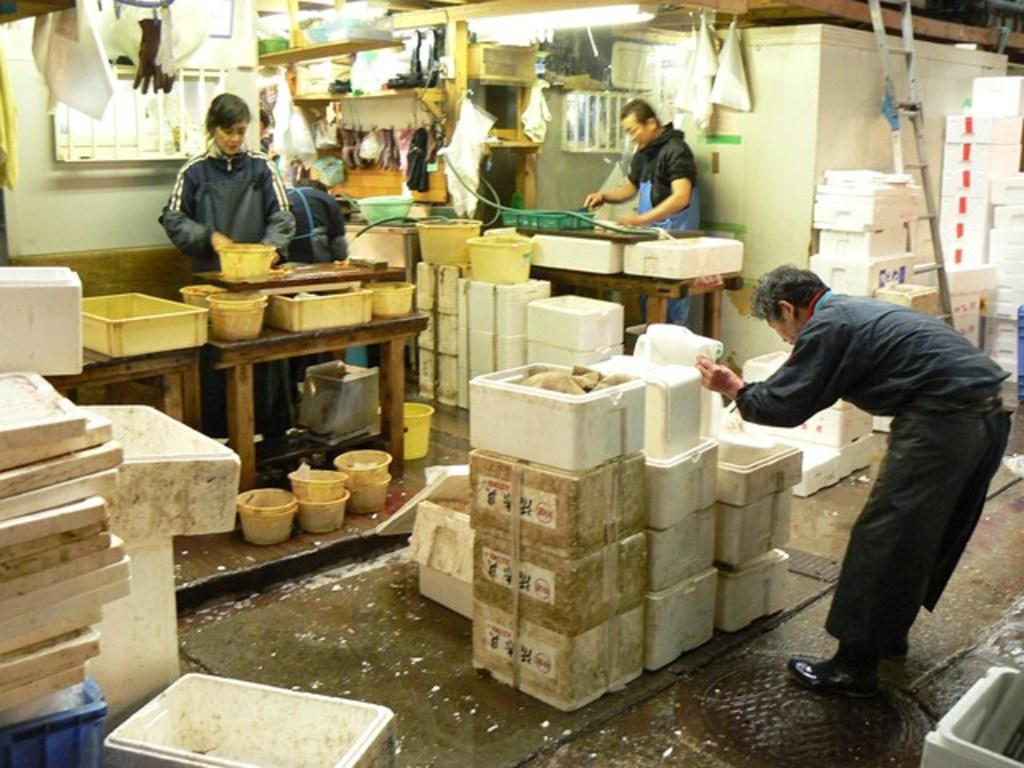How many people are in the image? There are three persons in the image. What objects can be seen in the image besides the people? There are boxes, baskets, bowls, tables, and gloves in the image. Can you describe the unspecified objects in the image? Unfortunately, the facts do not provide any information about the unspecified objects. What is visible in the background of the image? There is a wall in the background of the image. How many birds are perched on the tent in the image? There is no tent or birds present in the image. 